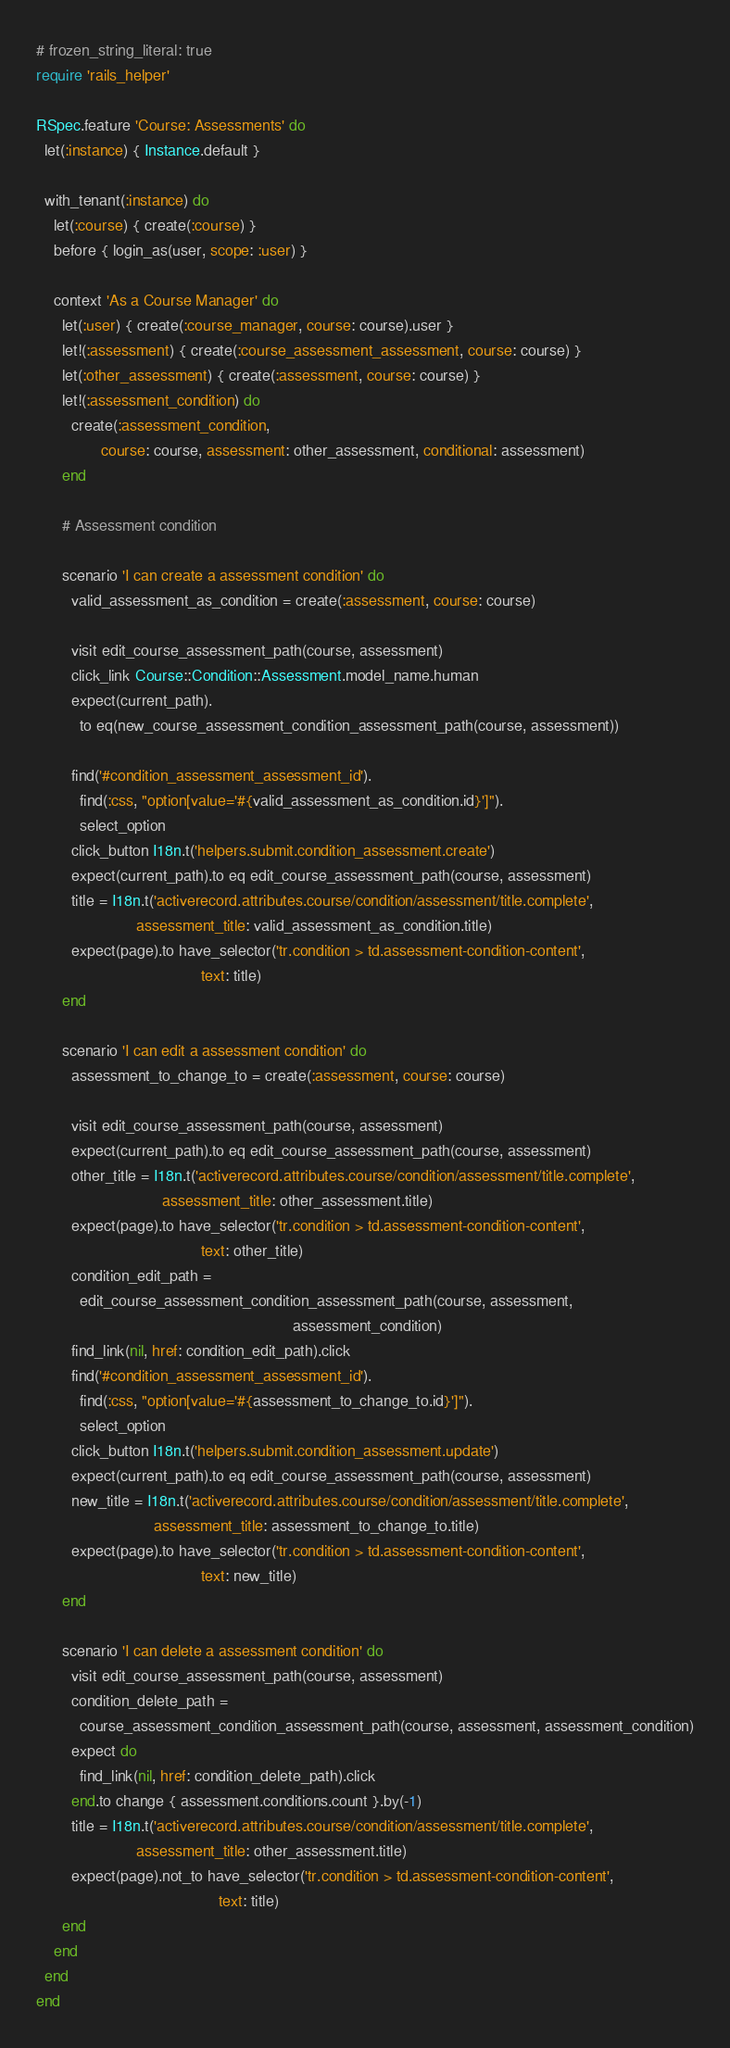<code> <loc_0><loc_0><loc_500><loc_500><_Ruby_># frozen_string_literal: true
require 'rails_helper'

RSpec.feature 'Course: Assessments' do
  let(:instance) { Instance.default }

  with_tenant(:instance) do
    let(:course) { create(:course) }
    before { login_as(user, scope: :user) }

    context 'As a Course Manager' do
      let(:user) { create(:course_manager, course: course).user }
      let!(:assessment) { create(:course_assessment_assessment, course: course) }
      let(:other_assessment) { create(:assessment, course: course) }
      let!(:assessment_condition) do
        create(:assessment_condition,
               course: course, assessment: other_assessment, conditional: assessment)
      end

      # Assessment condition

      scenario 'I can create a assessment condition' do
        valid_assessment_as_condition = create(:assessment, course: course)

        visit edit_course_assessment_path(course, assessment)
        click_link Course::Condition::Assessment.model_name.human
        expect(current_path).
          to eq(new_course_assessment_condition_assessment_path(course, assessment))

        find('#condition_assessment_assessment_id').
          find(:css, "option[value='#{valid_assessment_as_condition.id}']").
          select_option
        click_button I18n.t('helpers.submit.condition_assessment.create')
        expect(current_path).to eq edit_course_assessment_path(course, assessment)
        title = I18n.t('activerecord.attributes.course/condition/assessment/title.complete',
                       assessment_title: valid_assessment_as_condition.title)
        expect(page).to have_selector('tr.condition > td.assessment-condition-content',
                                      text: title)
      end

      scenario 'I can edit a assessment condition' do
        assessment_to_change_to = create(:assessment, course: course)

        visit edit_course_assessment_path(course, assessment)
        expect(current_path).to eq edit_course_assessment_path(course, assessment)
        other_title = I18n.t('activerecord.attributes.course/condition/assessment/title.complete',
                             assessment_title: other_assessment.title)
        expect(page).to have_selector('tr.condition > td.assessment-condition-content',
                                      text: other_title)
        condition_edit_path =
          edit_course_assessment_condition_assessment_path(course, assessment,
                                                           assessment_condition)
        find_link(nil, href: condition_edit_path).click
        find('#condition_assessment_assessment_id').
          find(:css, "option[value='#{assessment_to_change_to.id}']").
          select_option
        click_button I18n.t('helpers.submit.condition_assessment.update')
        expect(current_path).to eq edit_course_assessment_path(course, assessment)
        new_title = I18n.t('activerecord.attributes.course/condition/assessment/title.complete',
                           assessment_title: assessment_to_change_to.title)
        expect(page).to have_selector('tr.condition > td.assessment-condition-content',
                                      text: new_title)
      end

      scenario 'I can delete a assessment condition' do
        visit edit_course_assessment_path(course, assessment)
        condition_delete_path =
          course_assessment_condition_assessment_path(course, assessment, assessment_condition)
        expect do
          find_link(nil, href: condition_delete_path).click
        end.to change { assessment.conditions.count }.by(-1)
        title = I18n.t('activerecord.attributes.course/condition/assessment/title.complete',
                       assessment_title: other_assessment.title)
        expect(page).not_to have_selector('tr.condition > td.assessment-condition-content',
                                          text: title)
      end
    end
  end
end
</code> 